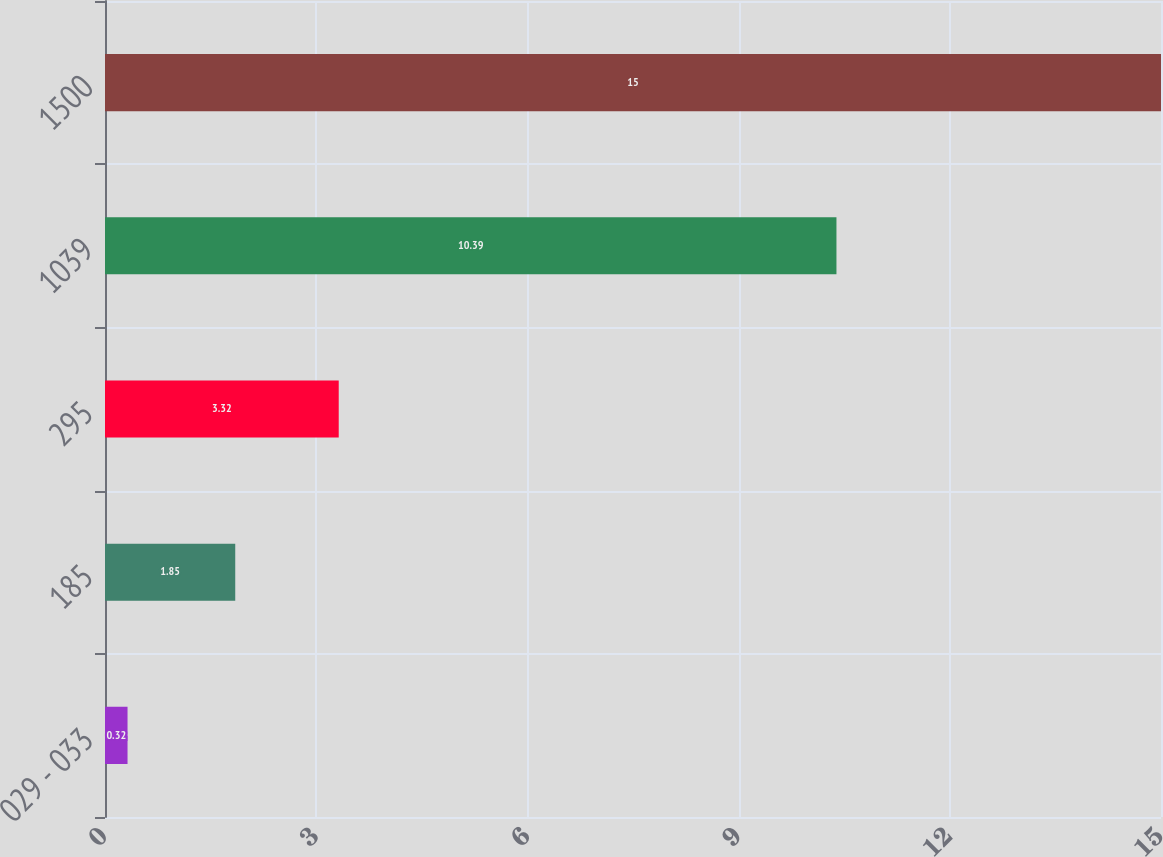Convert chart. <chart><loc_0><loc_0><loc_500><loc_500><bar_chart><fcel>029 - 033<fcel>185<fcel>295<fcel>1039<fcel>1500<nl><fcel>0.32<fcel>1.85<fcel>3.32<fcel>10.39<fcel>15<nl></chart> 